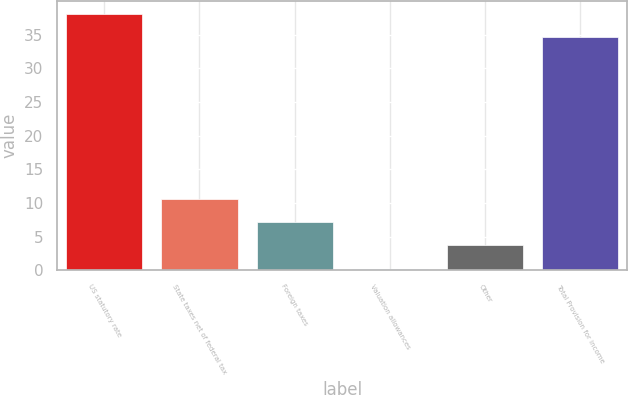Convert chart. <chart><loc_0><loc_0><loc_500><loc_500><bar_chart><fcel>US statutory rate<fcel>State taxes net of federal tax<fcel>Foreign taxes<fcel>Valuation allowances<fcel>Other<fcel>Total Provision for income<nl><fcel>38.08<fcel>10.64<fcel>7.16<fcel>0.2<fcel>3.68<fcel>34.6<nl></chart> 